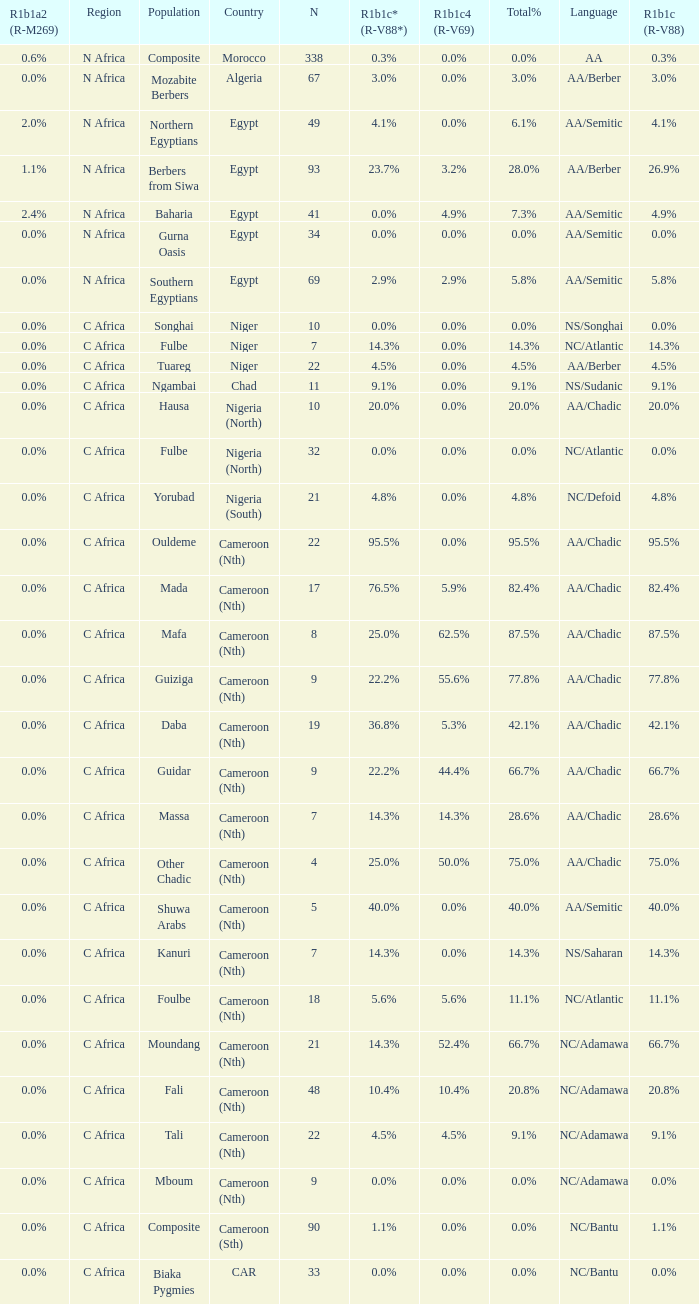How many n are documented for berbers from siwa? 1.0. 